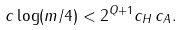Convert formula to latex. <formula><loc_0><loc_0><loc_500><loc_500>c \log ( m / 4 ) < 2 ^ { Q + 1 } c _ { H } \, c _ { A } .</formula> 